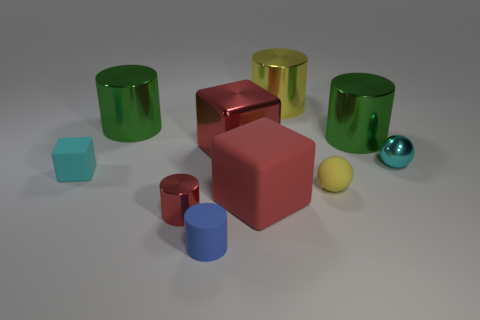There is a shiny cylinder in front of the cyan object on the right side of the yellow cylinder; what color is it?
Make the answer very short. Red. How many small objects are left of the small red cylinder and on the right side of the cyan matte object?
Make the answer very short. 0. Is the number of cyan rubber things greater than the number of big green objects?
Give a very brief answer. No. What is the cyan cube made of?
Your response must be concise. Rubber. There is a green shiny thing left of the small shiny cylinder; what number of yellow matte objects are in front of it?
Offer a terse response. 1. Do the metallic sphere and the large cube in front of the small cyan rubber thing have the same color?
Give a very brief answer. No. There is a shiny sphere that is the same size as the yellow matte ball; what is its color?
Give a very brief answer. Cyan. Are there any large red matte things that have the same shape as the tiny yellow object?
Make the answer very short. No. Is the number of tiny yellow cylinders less than the number of tiny cyan shiny balls?
Give a very brief answer. Yes. The small sphere left of the metal ball is what color?
Make the answer very short. Yellow. 